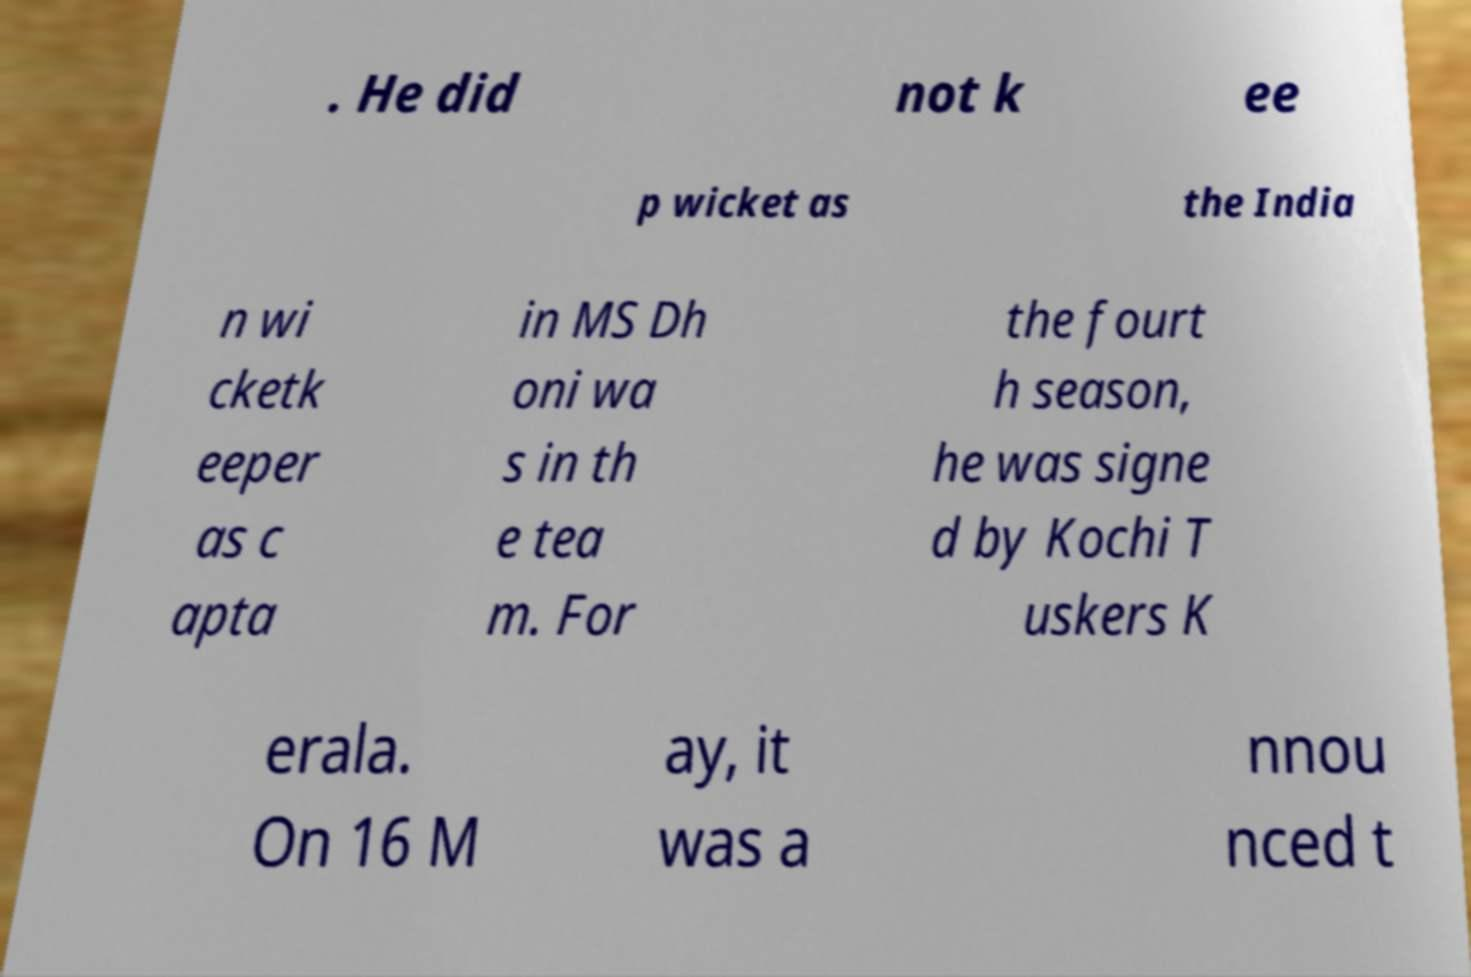Could you assist in decoding the text presented in this image and type it out clearly? . He did not k ee p wicket as the India n wi cketk eeper as c apta in MS Dh oni wa s in th e tea m. For the fourt h season, he was signe d by Kochi T uskers K erala. On 16 M ay, it was a nnou nced t 